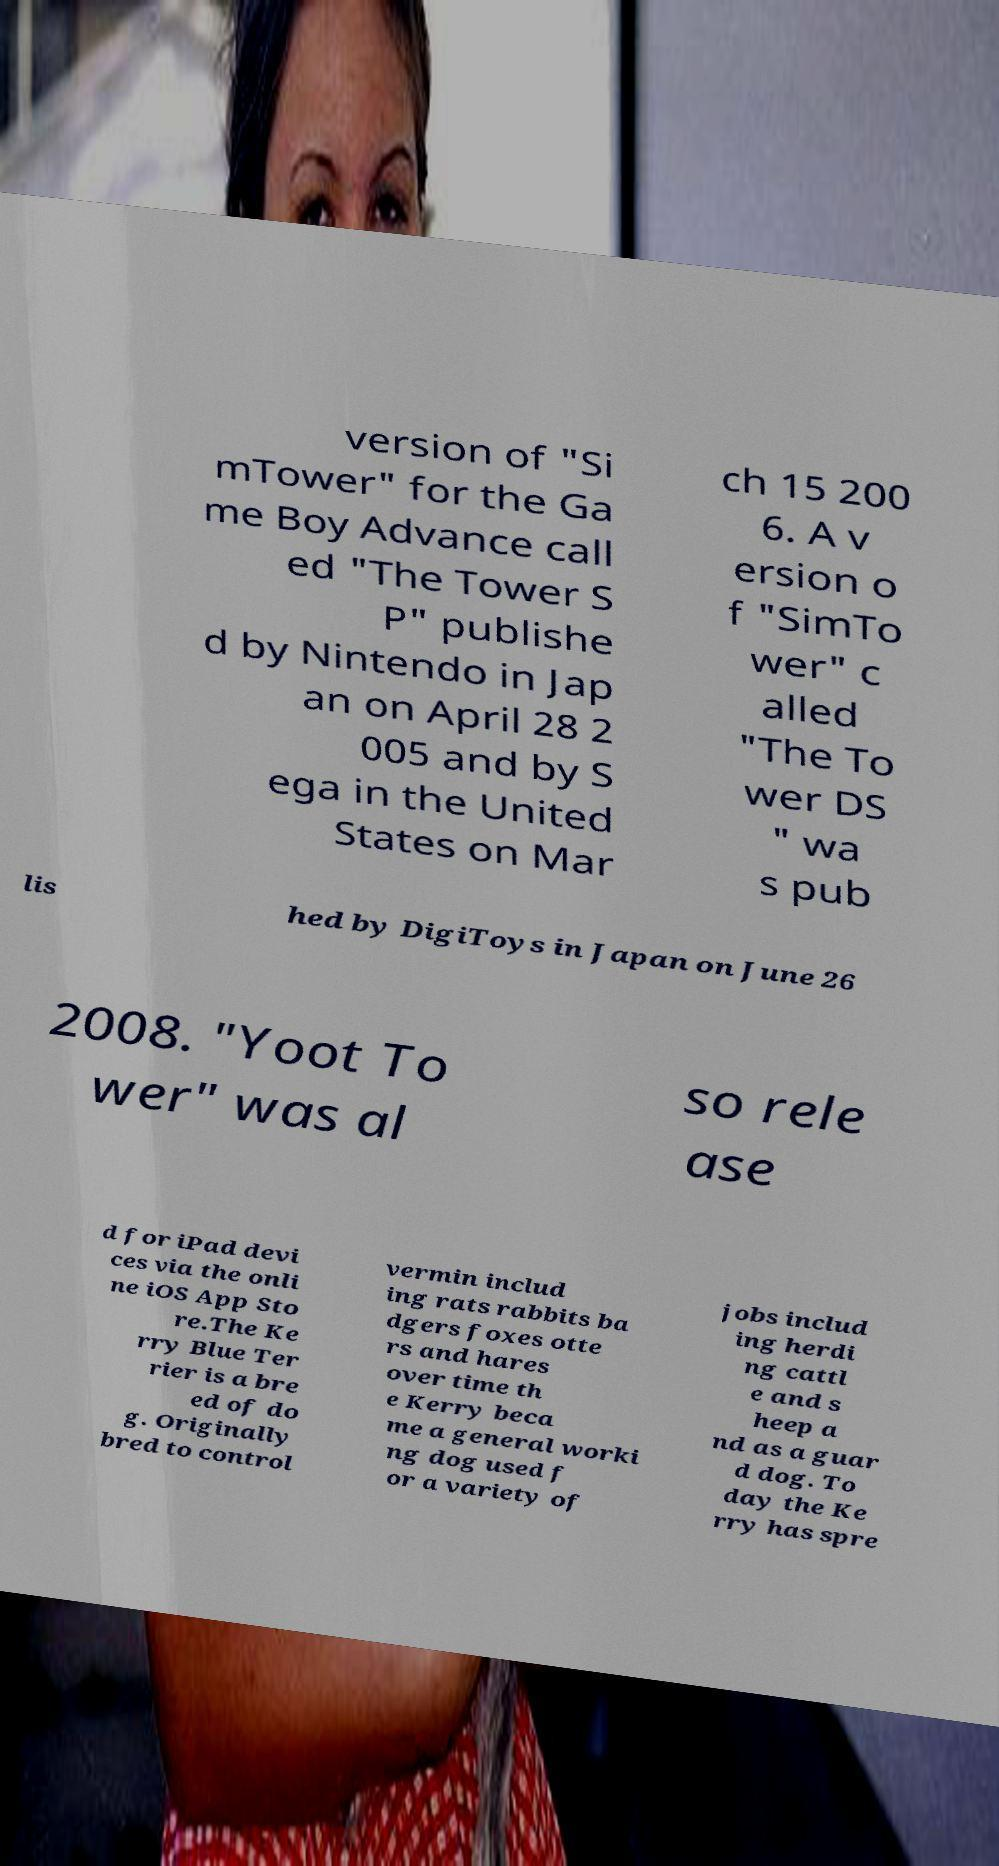Could you extract and type out the text from this image? version of "Si mTower" for the Ga me Boy Advance call ed "The Tower S P" publishe d by Nintendo in Jap an on April 28 2 005 and by S ega in the United States on Mar ch 15 200 6. A v ersion o f "SimTo wer" c alled "The To wer DS " wa s pub lis hed by DigiToys in Japan on June 26 2008. "Yoot To wer" was al so rele ase d for iPad devi ces via the onli ne iOS App Sto re.The Ke rry Blue Ter rier is a bre ed of do g. Originally bred to control vermin includ ing rats rabbits ba dgers foxes otte rs and hares over time th e Kerry beca me a general worki ng dog used f or a variety of jobs includ ing herdi ng cattl e and s heep a nd as a guar d dog. To day the Ke rry has spre 